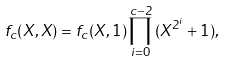<formula> <loc_0><loc_0><loc_500><loc_500>f _ { c } ( X , X ) = f _ { c } ( X , 1 ) \prod _ { i = 0 } ^ { c - 2 } \, ( X ^ { 2 ^ { i } } + 1 ) ,</formula> 